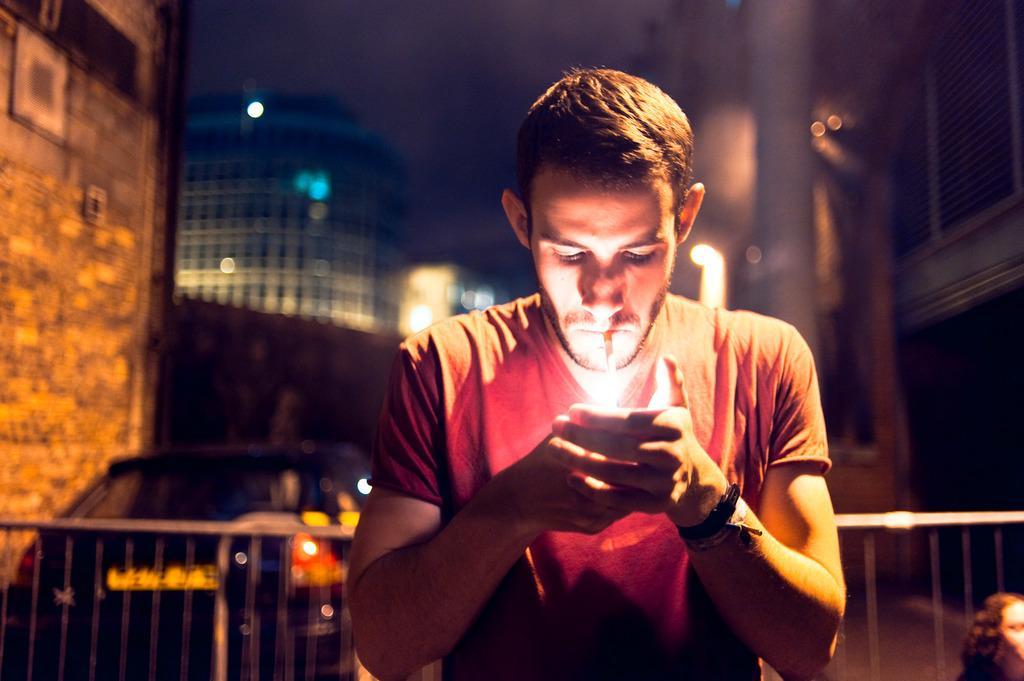Describe this image in one or two sentences. In this picture there is a person is wearing red color T-shirt and lighting a cigarette, behind him there is a fencing, car, on either side of him there are buildings. 